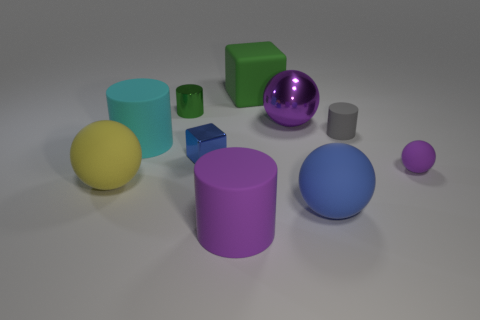Subtract all big blue rubber balls. How many balls are left? 3 Subtract all green cylinders. How many cylinders are left? 3 Subtract all cylinders. How many objects are left? 6 Subtract all purple blocks. How many cyan cylinders are left? 1 Add 2 tiny purple metallic cylinders. How many tiny purple metallic cylinders exist? 2 Subtract 1 green cubes. How many objects are left? 9 Subtract 1 balls. How many balls are left? 3 Subtract all blue cubes. Subtract all blue spheres. How many cubes are left? 1 Subtract all tiny gray spheres. Subtract all shiny cylinders. How many objects are left? 9 Add 9 small purple matte balls. How many small purple matte balls are left? 10 